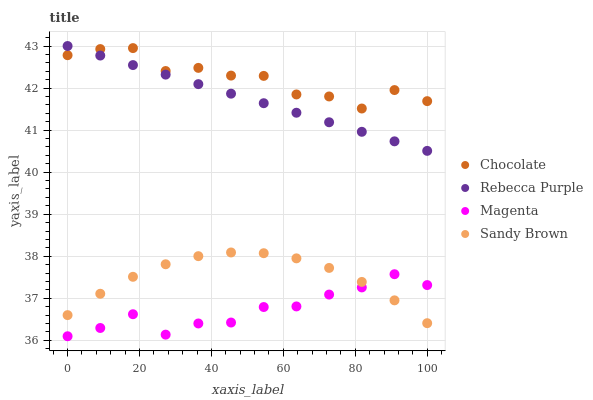Does Magenta have the minimum area under the curve?
Answer yes or no. Yes. Does Chocolate have the maximum area under the curve?
Answer yes or no. Yes. Does Sandy Brown have the minimum area under the curve?
Answer yes or no. No. Does Sandy Brown have the maximum area under the curve?
Answer yes or no. No. Is Rebecca Purple the smoothest?
Answer yes or no. Yes. Is Chocolate the roughest?
Answer yes or no. Yes. Is Sandy Brown the smoothest?
Answer yes or no. No. Is Sandy Brown the roughest?
Answer yes or no. No. Does Magenta have the lowest value?
Answer yes or no. Yes. Does Sandy Brown have the lowest value?
Answer yes or no. No. Does Rebecca Purple have the highest value?
Answer yes or no. Yes. Does Sandy Brown have the highest value?
Answer yes or no. No. Is Magenta less than Rebecca Purple?
Answer yes or no. Yes. Is Rebecca Purple greater than Magenta?
Answer yes or no. Yes. Does Sandy Brown intersect Magenta?
Answer yes or no. Yes. Is Sandy Brown less than Magenta?
Answer yes or no. No. Is Sandy Brown greater than Magenta?
Answer yes or no. No. Does Magenta intersect Rebecca Purple?
Answer yes or no. No. 